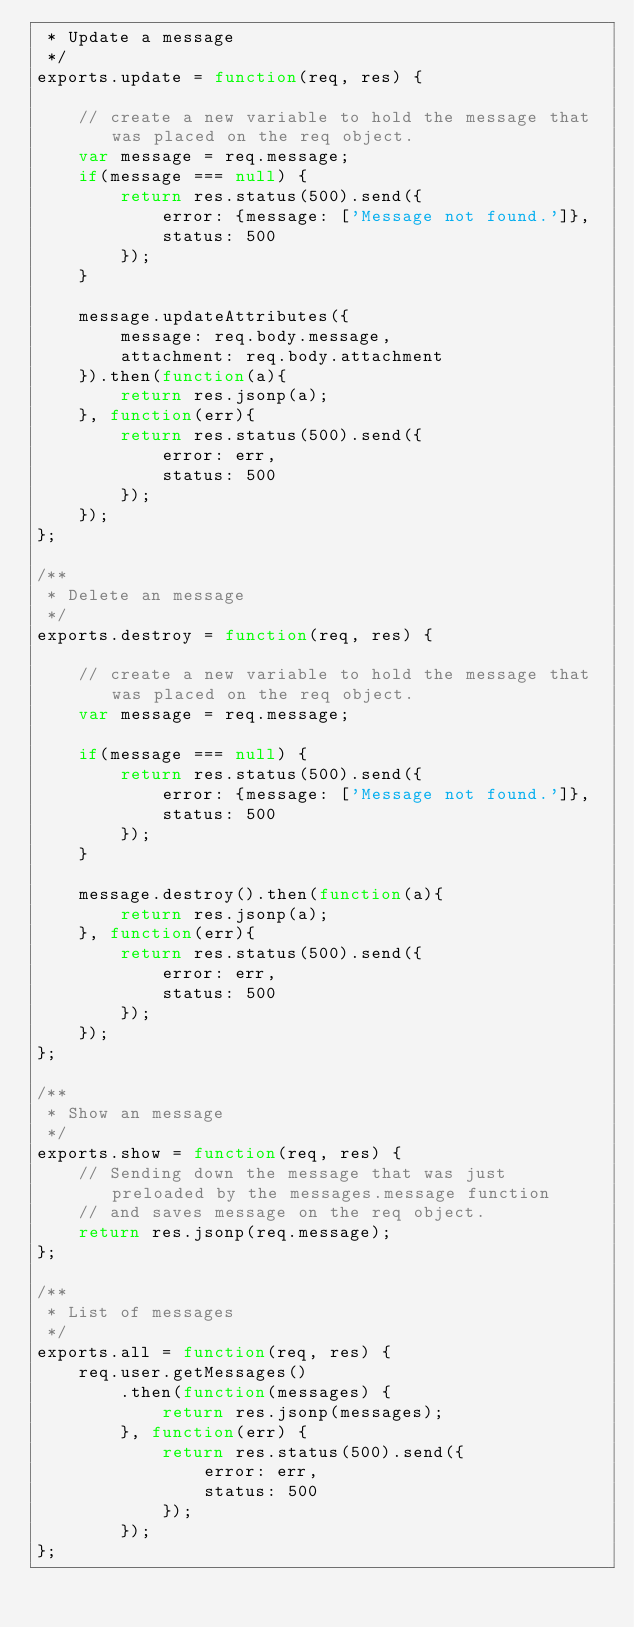<code> <loc_0><loc_0><loc_500><loc_500><_JavaScript_> * Update a message
 */
exports.update = function(req, res) {

    // create a new variable to hold the message that was placed on the req object.
    var message = req.message;
    if(message === null) {
        return res.status(500).send({
            error: {message: ['Message not found.']}, 
            status: 500
        });
    }

    message.updateAttributes({
        message: req.body.message,
        attachment: req.body.attachment
    }).then(function(a){
        return res.jsonp(a);
    }, function(err){
        return res.status(500).send({
            error: err, 
            status: 500
        });
    });
};

/**
 * Delete an message
 */
exports.destroy = function(req, res) {

    // create a new variable to hold the message that was placed on the req object.
    var message = req.message;

    if(message === null) {
        return res.status(500).send({
            error: {message: ['Message not found.']}, 
            status: 500
        });
    }

    message.destroy().then(function(a){
        return res.jsonp(a);
    }, function(err){
        return res.status(500).send({
            error: err, 
            status: 500
        });
    });
};

/**
 * Show an message
 */
exports.show = function(req, res) {
    // Sending down the message that was just preloaded by the messages.message function
    // and saves message on the req object.
    return res.jsonp(req.message);
};

/**
 * List of messages
 */
exports.all = function(req, res) {
    req.user.getMessages()
        .then(function(messages) {
            return res.jsonp(messages);
        }, function(err) {
            return res.status(500).send({
                error: err, 
                status: 500
            });
        });
};</code> 